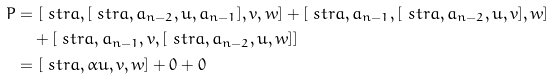<formula> <loc_0><loc_0><loc_500><loc_500>P & = [ \ s t r { a } , [ \ s t r { a } , a _ { n - 2 } , u , a _ { n - 1 } ] , v , w ] + [ \ s t r { a } , a _ { n - 1 } , [ \ s t r { a } , a _ { n - 2 } , u , v ] , w ] \\ & \quad + [ \ s t r { a } , a _ { n - 1 } , v , [ \ s t r { a } , a _ { n - 2 } , u , w ] ] \\ & = [ \ s t r { a } , \alpha u , v , w ] + 0 + 0 \\</formula> 